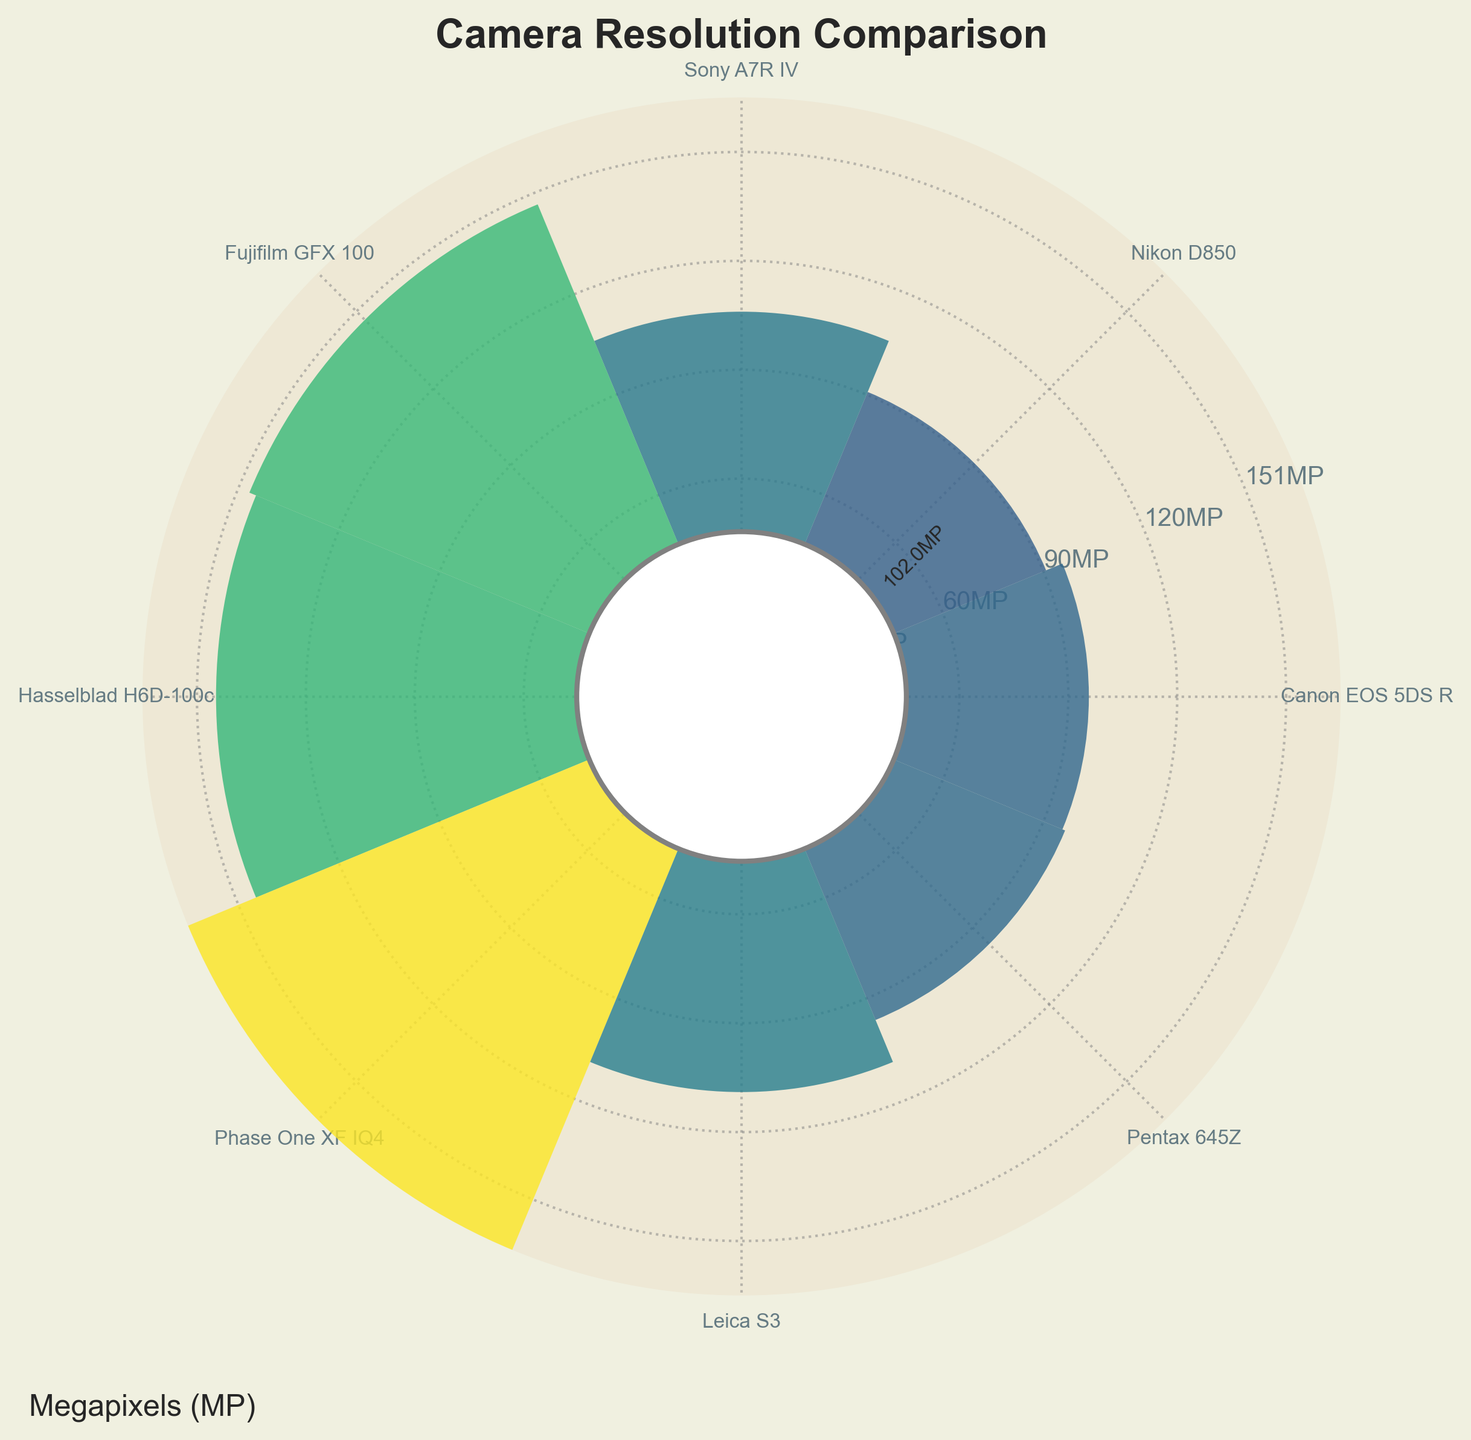what’s the title of the chart? The title of the chart is located at the top and clearly states what the chart is about.
Answer: Camera Resolution Comparison How many cameras are compared in the chart? The chart bars represent the number of cameras. By counting these bars, we find the total number of cameras compared.
Answer: 8 Which camera has the highest megapixels? The height of the bars indicates the megapixels. The tallest bar represents the camera with the highest megapixels.
Answer: Phase One XF IQ4 Which camera has a higher resolution, Canon EOS 5DS R or Pentax 645Z? Compare the bar heights of Canon EOS 5DS R and Pentax 645Z to determine which is taller.
Answer: Pentax 645Z What is the megapixels value of the Sony A7R IV? Look at the height of the bar for Sony A7R IV and read the numerical value annotated near it.
Answer: 61MP What's the range of megapixels among the cameras? Subtract the smallest megapixels value from the largest value to get the range. The smallest is Canon EOS 5DS R (50.6MP) and the largest is Phase One XF IQ4 (151MP). 151MP - 50.6MP = 100.4MP
Answer: 100.4MP Calculate the average resolution of the cameras shown? Sum the megapixels of all cameras and divide by the number of cameras. Use the values: 50.6, 45.7, 61, 102, 100, 151, 64, 51.4. Average = (50.6 + 45.7 + 61 + 102 + 100 + 151 + 64 + 51.4)/8 = 78.46
Answer: 78.46MP Which camera has the closest resolution to 100 megapixels? Find the cameras with resolution values near 100MP, such as Fujifilm GFX 100 (102MP) and Hasselblad H6D-100c (100MP) based on the bar heights and annotated value.
Answer: Hasselblad H6D-100c By how many megapixels does the Sony A7R IV surpasses Nikon D850? Subtract Nikon D850's megapixels from Sony A7R IV's megapixels to find the difference. 61MP - 45.7MP = 15.3MP
Answer: 15.3MP 